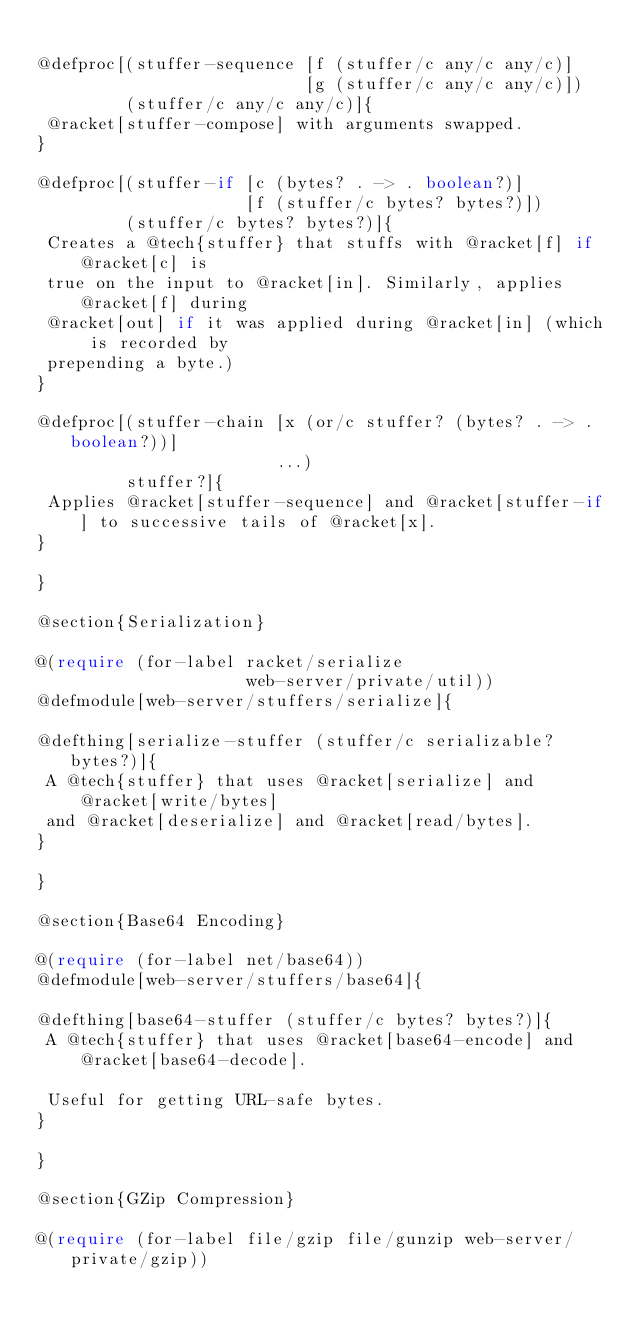<code> <loc_0><loc_0><loc_500><loc_500><_Racket_>
@defproc[(stuffer-sequence [f (stuffer/c any/c any/c)]
                           [g (stuffer/c any/c any/c)])
         (stuffer/c any/c any/c)]{
 @racket[stuffer-compose] with arguments swapped.
}

@defproc[(stuffer-if [c (bytes? . -> . boolean?)]
                     [f (stuffer/c bytes? bytes?)])
         (stuffer/c bytes? bytes?)]{
 Creates a @tech{stuffer} that stuffs with @racket[f] if @racket[c] is
 true on the input to @racket[in]. Similarly, applies @racket[f] during
 @racket[out] if it was applied during @racket[in] (which is recorded by
 prepending a byte.)
}

@defproc[(stuffer-chain [x (or/c stuffer? (bytes? . -> . boolean?))]
                        ...)
         stuffer?]{
 Applies @racket[stuffer-sequence] and @racket[stuffer-if] to successive tails of @racket[x].
}
                  
}

@section{Serialization}

@(require (for-label racket/serialize
                     web-server/private/util))
@defmodule[web-server/stuffers/serialize]{

@defthing[serialize-stuffer (stuffer/c serializable? bytes?)]{
 A @tech{stuffer} that uses @racket[serialize] and @racket[write/bytes]
 and @racket[deserialize] and @racket[read/bytes].
}

}

@section{Base64 Encoding}

@(require (for-label net/base64))
@defmodule[web-server/stuffers/base64]{

@defthing[base64-stuffer (stuffer/c bytes? bytes?)]{
 A @tech{stuffer} that uses @racket[base64-encode] and @racket[base64-decode].
   
 Useful for getting URL-safe bytes.
}
         
}

@section{GZip Compression}

@(require (for-label file/gzip file/gunzip web-server/private/gzip))</code> 